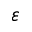Convert formula to latex. <formula><loc_0><loc_0><loc_500><loc_500>\varepsilon</formula> 